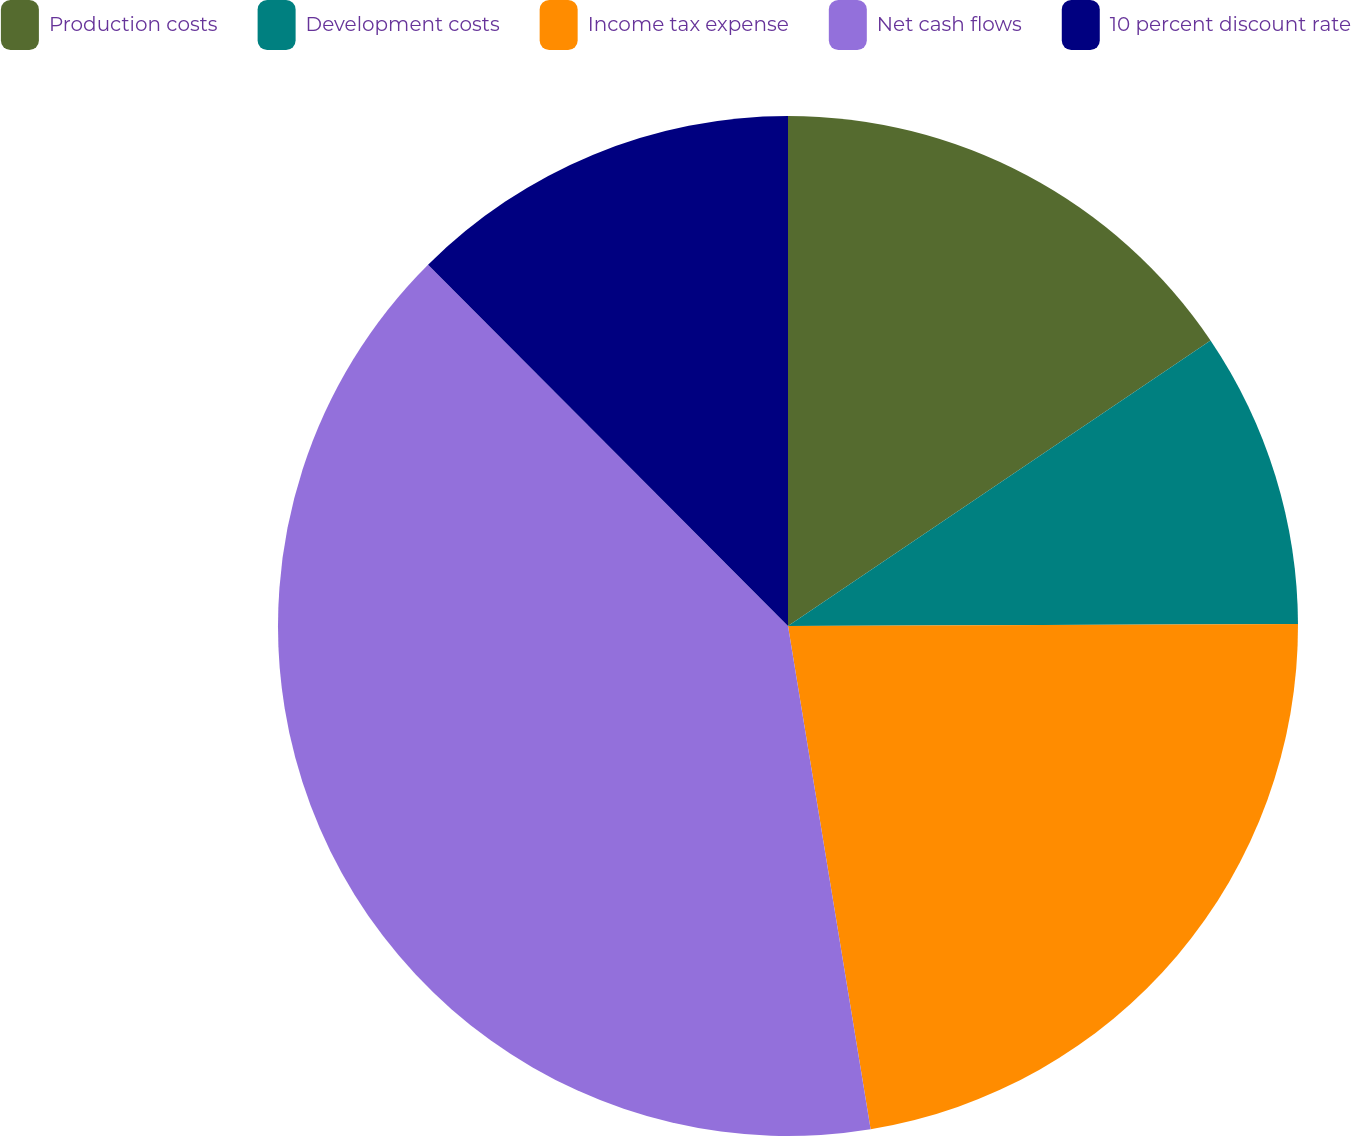Convert chart. <chart><loc_0><loc_0><loc_500><loc_500><pie_chart><fcel>Production costs<fcel>Development costs<fcel>Income tax expense<fcel>Net cash flows<fcel>10 percent discount rate<nl><fcel>15.54%<fcel>9.4%<fcel>22.47%<fcel>40.12%<fcel>12.47%<nl></chart> 